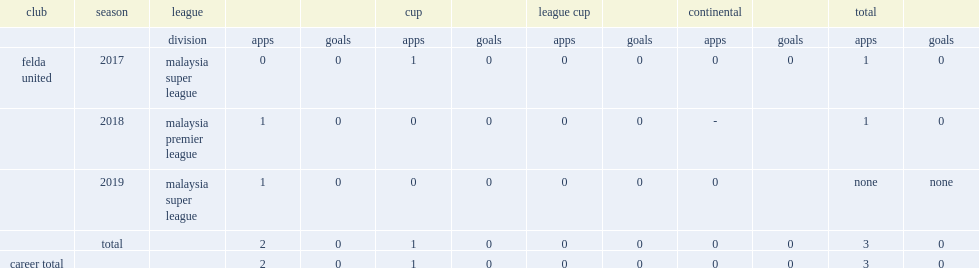In 2018, which league did ali debute for felda united in? Malaysia premier league. 